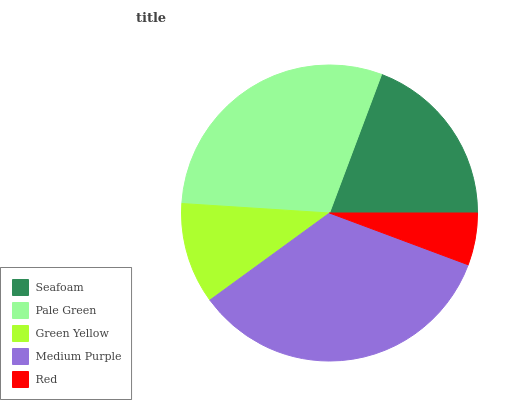Is Red the minimum?
Answer yes or no. Yes. Is Medium Purple the maximum?
Answer yes or no. Yes. Is Pale Green the minimum?
Answer yes or no. No. Is Pale Green the maximum?
Answer yes or no. No. Is Pale Green greater than Seafoam?
Answer yes or no. Yes. Is Seafoam less than Pale Green?
Answer yes or no. Yes. Is Seafoam greater than Pale Green?
Answer yes or no. No. Is Pale Green less than Seafoam?
Answer yes or no. No. Is Seafoam the high median?
Answer yes or no. Yes. Is Seafoam the low median?
Answer yes or no. Yes. Is Green Yellow the high median?
Answer yes or no. No. Is Medium Purple the low median?
Answer yes or no. No. 